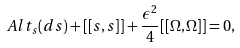<formula> <loc_0><loc_0><loc_500><loc_500>A l t _ { s } ( d s ) + [ [ s , s ] ] + \frac { \epsilon ^ { 2 } } { 4 } [ [ \Omega , \Omega ] ] = 0 ,</formula> 